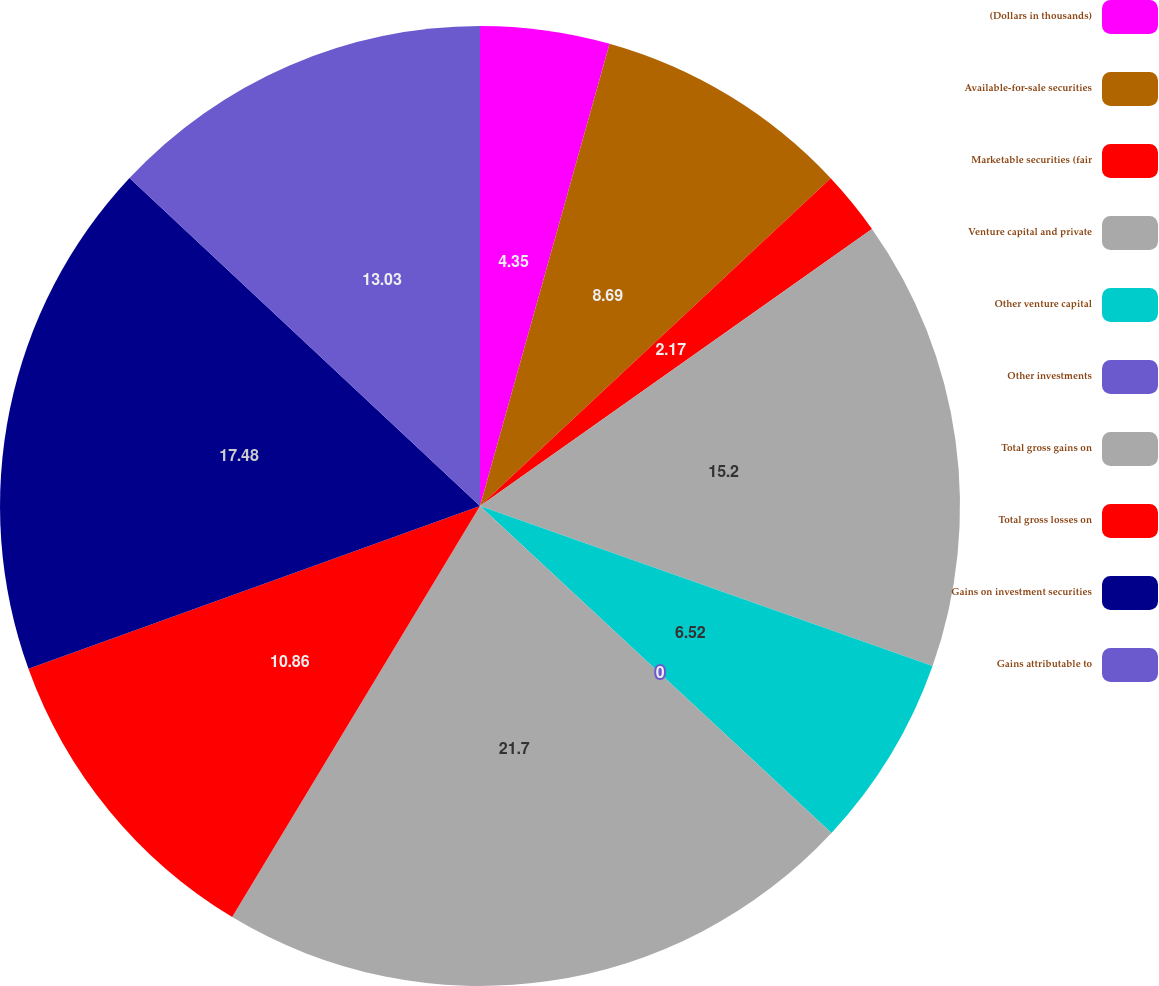Convert chart. <chart><loc_0><loc_0><loc_500><loc_500><pie_chart><fcel>(Dollars in thousands)<fcel>Available-for-sale securities<fcel>Marketable securities (fair<fcel>Venture capital and private<fcel>Other venture capital<fcel>Other investments<fcel>Total gross gains on<fcel>Total gross losses on<fcel>Gains on investment securities<fcel>Gains attributable to<nl><fcel>4.35%<fcel>8.69%<fcel>2.17%<fcel>15.2%<fcel>6.52%<fcel>0.0%<fcel>21.71%<fcel>10.86%<fcel>17.48%<fcel>13.03%<nl></chart> 